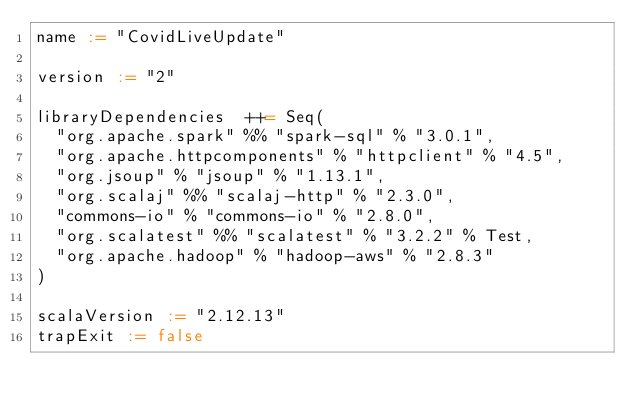<code> <loc_0><loc_0><loc_500><loc_500><_Scala_>name := "CovidLiveUpdate"

version := "2"

libraryDependencies  ++= Seq(
  "org.apache.spark" %% "spark-sql" % "3.0.1",
  "org.apache.httpcomponents" % "httpclient" % "4.5",
  "org.jsoup" % "jsoup" % "1.13.1",
  "org.scalaj" %% "scalaj-http" % "2.3.0",
  "commons-io" % "commons-io" % "2.8.0",
  "org.scalatest" %% "scalatest" % "3.2.2" % Test,
  "org.apache.hadoop" % "hadoop-aws" % "2.8.3"
)

scalaVersion := "2.12.13"
trapExit := false</code> 